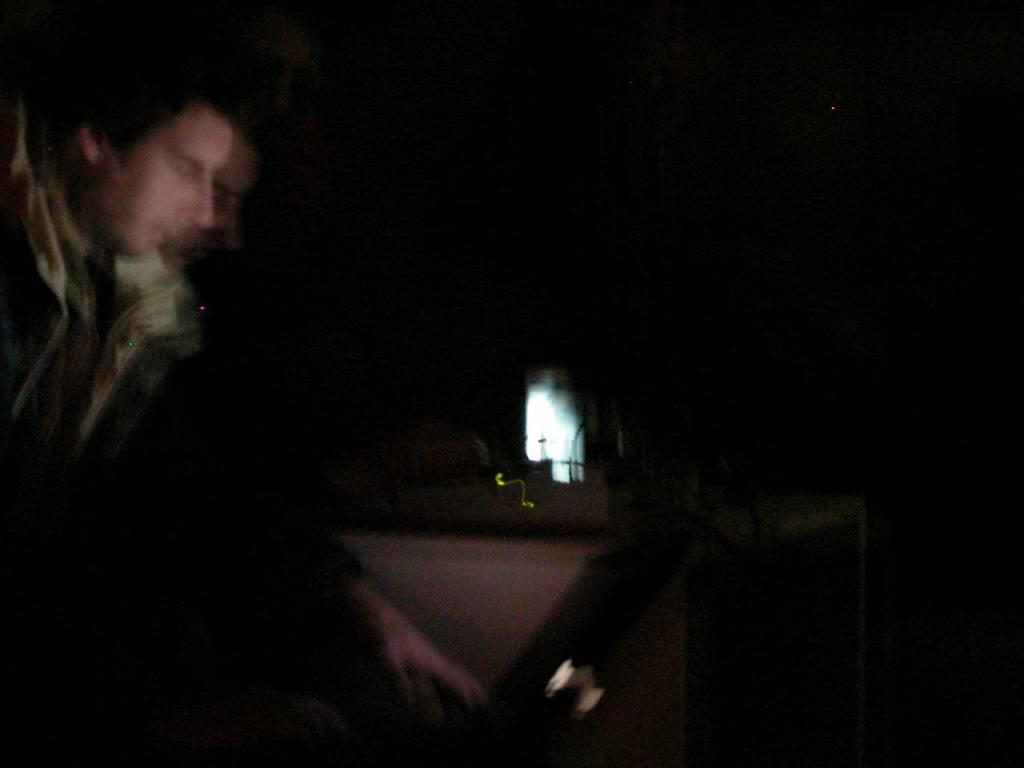Who is the main subject in the foreground of the image? There is a man in the foreground of the image. What is the lighting condition in the image? The man and the laptop are in a dark setting. What object is also present in the foreground of the image? There is a laptop in the foreground of the image. Can you tell me how many times the man jumps in the image? There is no indication of the man jumping in the image; he is standing or sitting with a laptop. What type of joke is the man telling in the image? There is no indication of the man telling a joke in the image; he is focused on the laptop. 